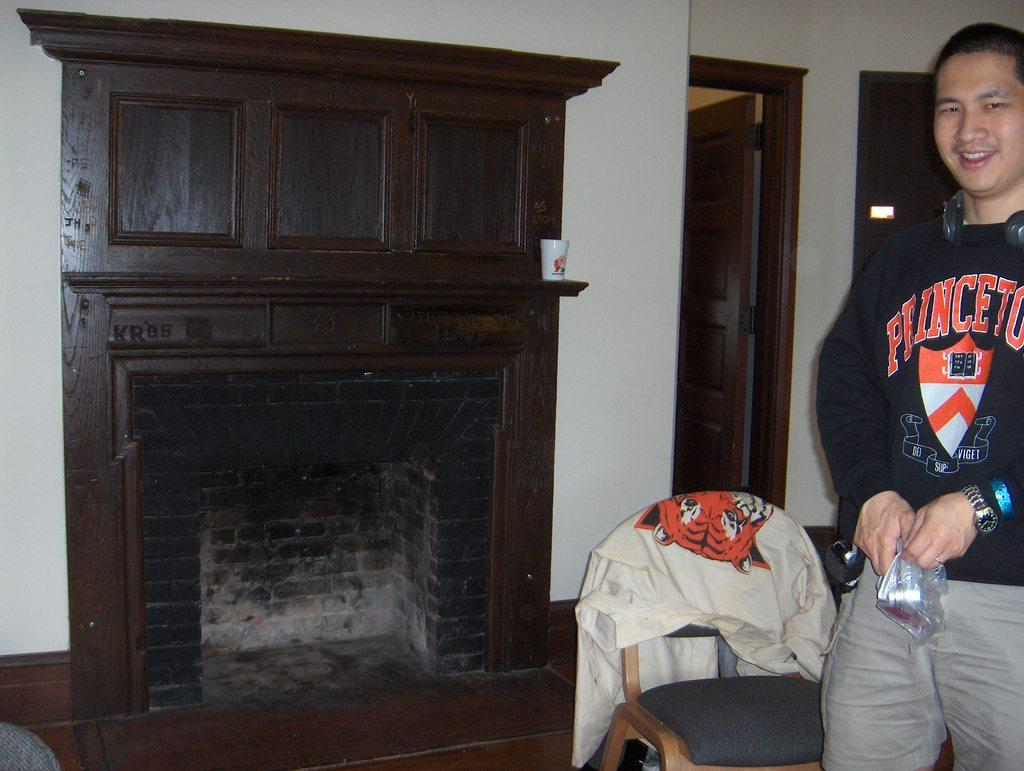<image>
Create a compact narrative representing the image presented. A man wearing a Princeton sweatshirt is standing near a fireplace. 